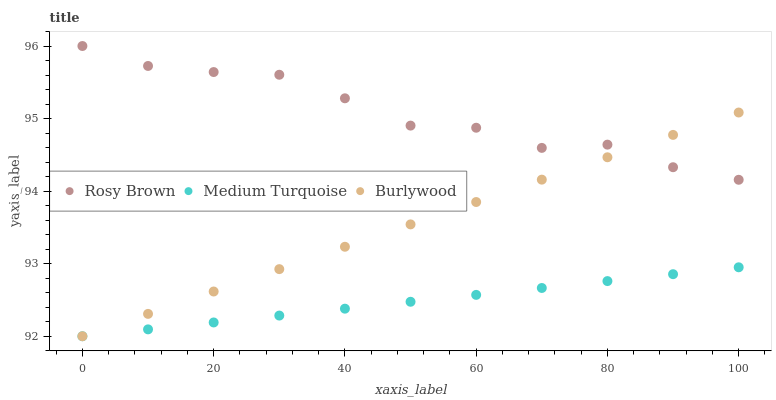Does Medium Turquoise have the minimum area under the curve?
Answer yes or no. Yes. Does Rosy Brown have the maximum area under the curve?
Answer yes or no. Yes. Does Rosy Brown have the minimum area under the curve?
Answer yes or no. No. Does Medium Turquoise have the maximum area under the curve?
Answer yes or no. No. Is Burlywood the smoothest?
Answer yes or no. Yes. Is Rosy Brown the roughest?
Answer yes or no. Yes. Is Medium Turquoise the smoothest?
Answer yes or no. No. Is Medium Turquoise the roughest?
Answer yes or no. No. Does Burlywood have the lowest value?
Answer yes or no. Yes. Does Rosy Brown have the lowest value?
Answer yes or no. No. Does Rosy Brown have the highest value?
Answer yes or no. Yes. Does Medium Turquoise have the highest value?
Answer yes or no. No. Is Medium Turquoise less than Rosy Brown?
Answer yes or no. Yes. Is Rosy Brown greater than Medium Turquoise?
Answer yes or no. Yes. Does Medium Turquoise intersect Burlywood?
Answer yes or no. Yes. Is Medium Turquoise less than Burlywood?
Answer yes or no. No. Is Medium Turquoise greater than Burlywood?
Answer yes or no. No. Does Medium Turquoise intersect Rosy Brown?
Answer yes or no. No. 